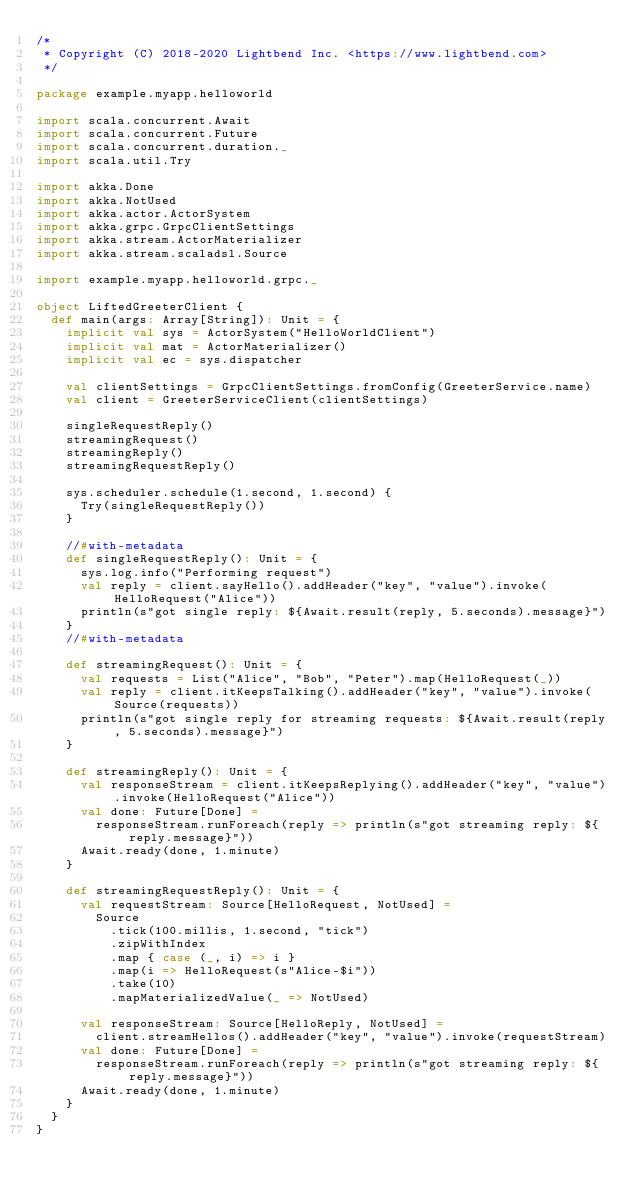<code> <loc_0><loc_0><loc_500><loc_500><_Scala_>/*
 * Copyright (C) 2018-2020 Lightbend Inc. <https://www.lightbend.com>
 */

package example.myapp.helloworld

import scala.concurrent.Await
import scala.concurrent.Future
import scala.concurrent.duration._
import scala.util.Try

import akka.Done
import akka.NotUsed
import akka.actor.ActorSystem
import akka.grpc.GrpcClientSettings
import akka.stream.ActorMaterializer
import akka.stream.scaladsl.Source

import example.myapp.helloworld.grpc._

object LiftedGreeterClient {
  def main(args: Array[String]): Unit = {
    implicit val sys = ActorSystem("HelloWorldClient")
    implicit val mat = ActorMaterializer()
    implicit val ec = sys.dispatcher

    val clientSettings = GrpcClientSettings.fromConfig(GreeterService.name)
    val client = GreeterServiceClient(clientSettings)

    singleRequestReply()
    streamingRequest()
    streamingReply()
    streamingRequestReply()

    sys.scheduler.schedule(1.second, 1.second) {
      Try(singleRequestReply())
    }

    //#with-metadata
    def singleRequestReply(): Unit = {
      sys.log.info("Performing request")
      val reply = client.sayHello().addHeader("key", "value").invoke(HelloRequest("Alice"))
      println(s"got single reply: ${Await.result(reply, 5.seconds).message}")
    }
    //#with-metadata

    def streamingRequest(): Unit = {
      val requests = List("Alice", "Bob", "Peter").map(HelloRequest(_))
      val reply = client.itKeepsTalking().addHeader("key", "value").invoke(Source(requests))
      println(s"got single reply for streaming requests: ${Await.result(reply, 5.seconds).message}")
    }

    def streamingReply(): Unit = {
      val responseStream = client.itKeepsReplying().addHeader("key", "value").invoke(HelloRequest("Alice"))
      val done: Future[Done] =
        responseStream.runForeach(reply => println(s"got streaming reply: ${reply.message}"))
      Await.ready(done, 1.minute)
    }

    def streamingRequestReply(): Unit = {
      val requestStream: Source[HelloRequest, NotUsed] =
        Source
          .tick(100.millis, 1.second, "tick")
          .zipWithIndex
          .map { case (_, i) => i }
          .map(i => HelloRequest(s"Alice-$i"))
          .take(10)
          .mapMaterializedValue(_ => NotUsed)

      val responseStream: Source[HelloReply, NotUsed] =
        client.streamHellos().addHeader("key", "value").invoke(requestStream)
      val done: Future[Done] =
        responseStream.runForeach(reply => println(s"got streaming reply: ${reply.message}"))
      Await.ready(done, 1.minute)
    }
  }
}
</code> 